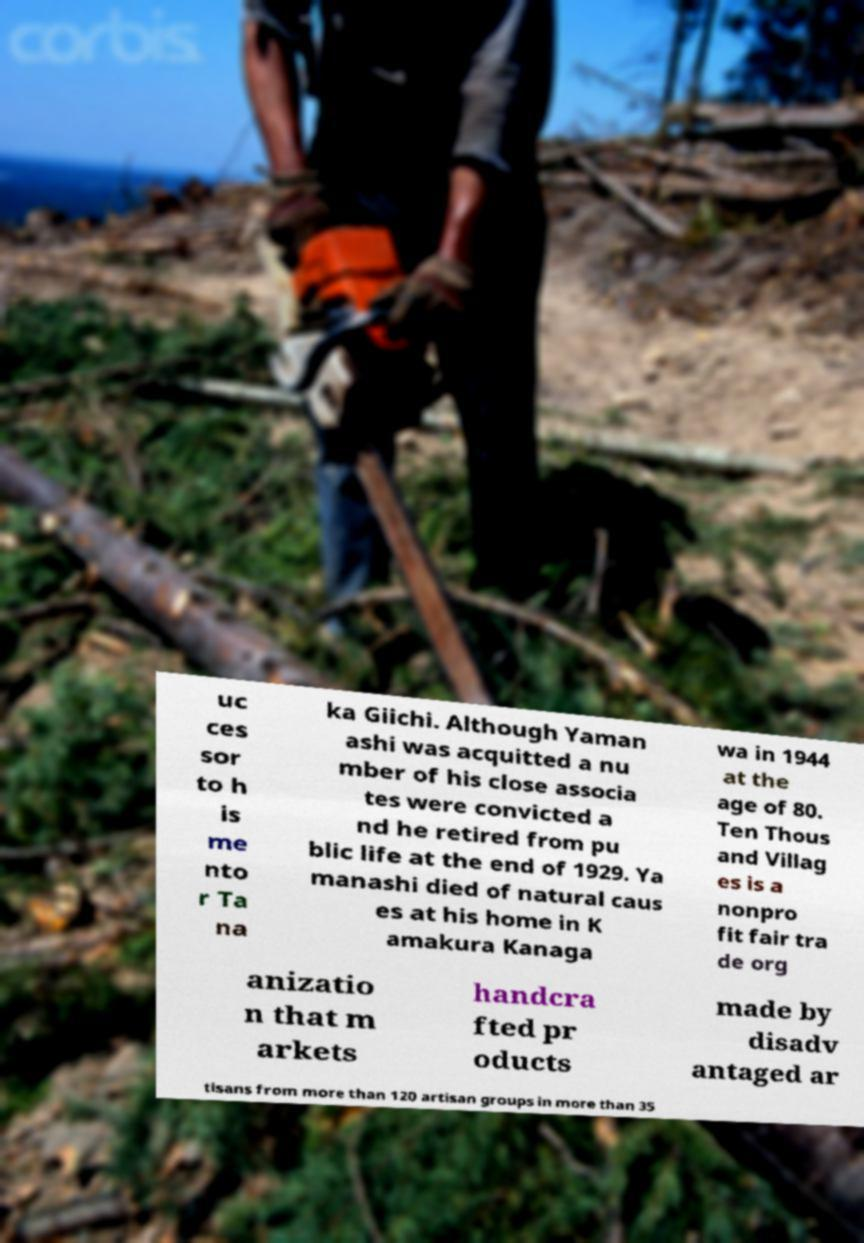Please read and relay the text visible in this image. What does it say? uc ces sor to h is me nto r Ta na ka Giichi. Although Yaman ashi was acquitted a nu mber of his close associa tes were convicted a nd he retired from pu blic life at the end of 1929. Ya manashi died of natural caus es at his home in K amakura Kanaga wa in 1944 at the age of 80. Ten Thous and Villag es is a nonpro fit fair tra de org anizatio n that m arkets handcra fted pr oducts made by disadv antaged ar tisans from more than 120 artisan groups in more than 35 